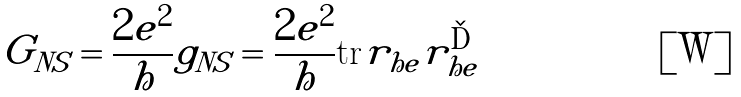<formula> <loc_0><loc_0><loc_500><loc_500>G _ { N S } = \frac { 2 e ^ { 2 } } { h } g _ { N S } = \frac { 2 e ^ { 2 } } { h } \text {tr} r _ { h e } r _ { h e } ^ { \dag }</formula> 